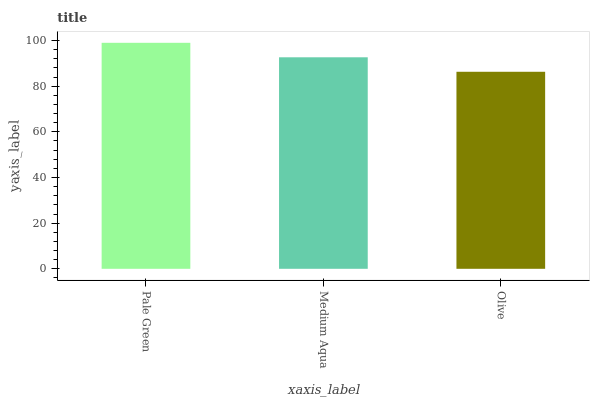Is Olive the minimum?
Answer yes or no. Yes. Is Pale Green the maximum?
Answer yes or no. Yes. Is Medium Aqua the minimum?
Answer yes or no. No. Is Medium Aqua the maximum?
Answer yes or no. No. Is Pale Green greater than Medium Aqua?
Answer yes or no. Yes. Is Medium Aqua less than Pale Green?
Answer yes or no. Yes. Is Medium Aqua greater than Pale Green?
Answer yes or no. No. Is Pale Green less than Medium Aqua?
Answer yes or no. No. Is Medium Aqua the high median?
Answer yes or no. Yes. Is Medium Aqua the low median?
Answer yes or no. Yes. Is Olive the high median?
Answer yes or no. No. Is Pale Green the low median?
Answer yes or no. No. 